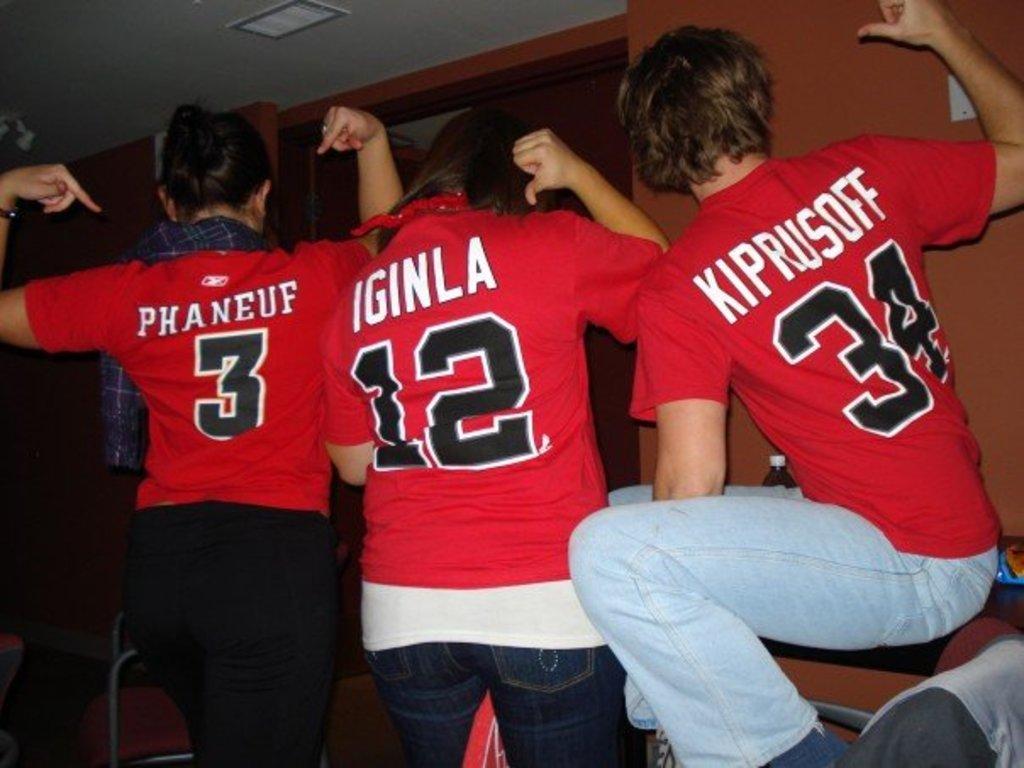What is the name of player number 3?
Provide a short and direct response. Phaneuf. What is the name of the person wearing #34?
Provide a short and direct response. Kiprusoff. 